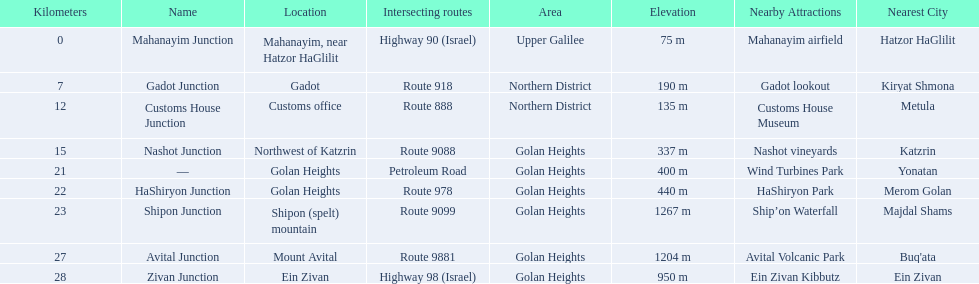What are all of the junction names? Mahanayim Junction, Gadot Junction, Customs House Junction, Nashot Junction, —, HaShiryon Junction, Shipon Junction, Avital Junction, Zivan Junction. What are their locations in kilometers? 0, 7, 12, 15, 21, 22, 23, 27, 28. Between shipon and avital, whicih is nashot closer to? Shipon Junction. 